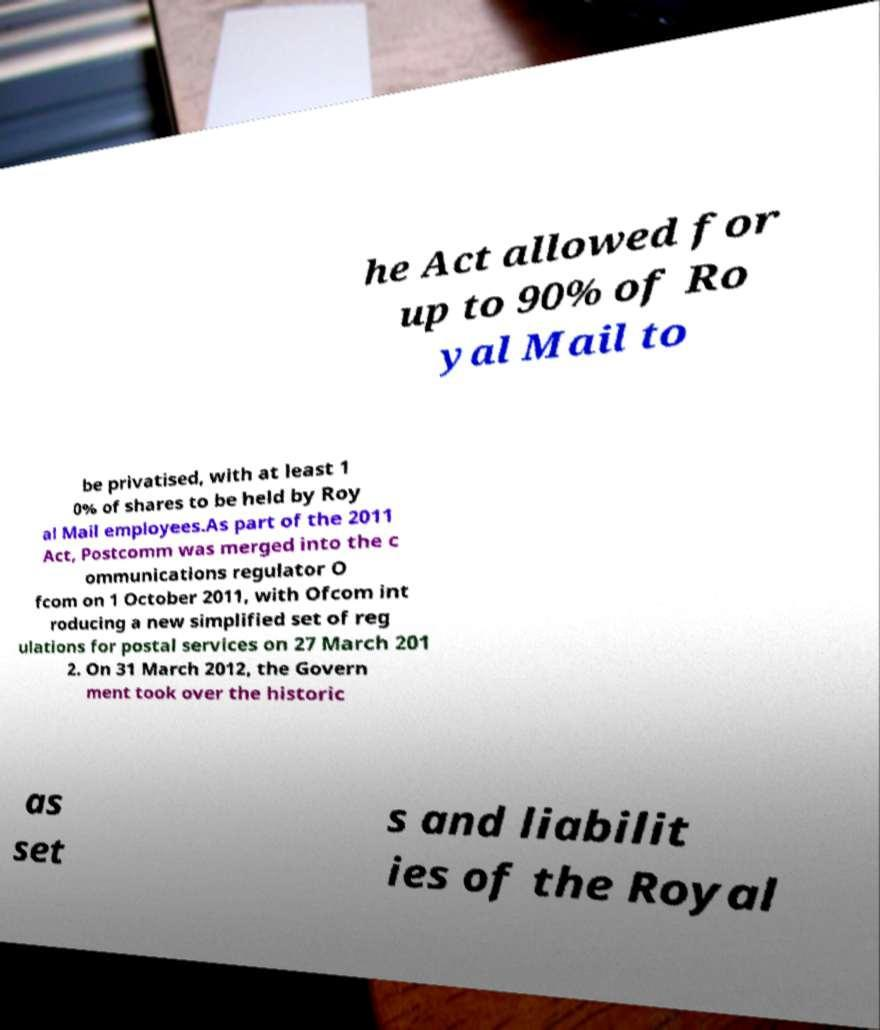Can you accurately transcribe the text from the provided image for me? he Act allowed for up to 90% of Ro yal Mail to be privatised, with at least 1 0% of shares to be held by Roy al Mail employees.As part of the 2011 Act, Postcomm was merged into the c ommunications regulator O fcom on 1 October 2011, with Ofcom int roducing a new simplified set of reg ulations for postal services on 27 March 201 2. On 31 March 2012, the Govern ment took over the historic as set s and liabilit ies of the Royal 